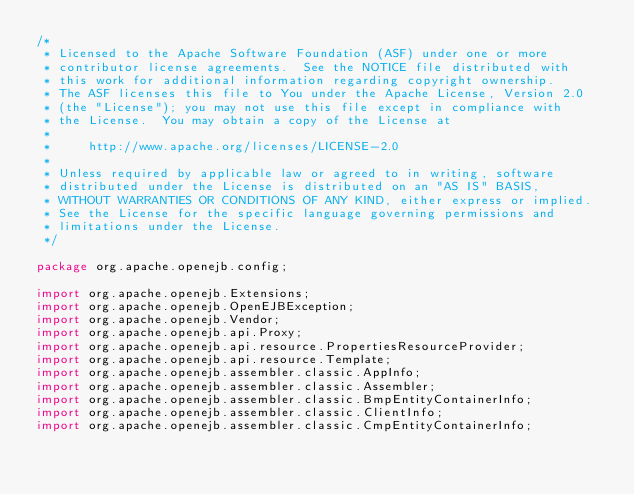Convert code to text. <code><loc_0><loc_0><loc_500><loc_500><_Java_>/*
 * Licensed to the Apache Software Foundation (ASF) under one or more
 * contributor license agreements.  See the NOTICE file distributed with
 * this work for additional information regarding copyright ownership.
 * The ASF licenses this file to You under the Apache License, Version 2.0
 * (the "License"); you may not use this file except in compliance with
 * the License.  You may obtain a copy of the License at
 *
 *     http://www.apache.org/licenses/LICENSE-2.0
 *
 * Unless required by applicable law or agreed to in writing, software
 * distributed under the License is distributed on an "AS IS" BASIS,
 * WITHOUT WARRANTIES OR CONDITIONS OF ANY KIND, either express or implied.
 * See the License for the specific language governing permissions and
 * limitations under the License.
 */

package org.apache.openejb.config;

import org.apache.openejb.Extensions;
import org.apache.openejb.OpenEJBException;
import org.apache.openejb.Vendor;
import org.apache.openejb.api.Proxy;
import org.apache.openejb.api.resource.PropertiesResourceProvider;
import org.apache.openejb.api.resource.Template;
import org.apache.openejb.assembler.classic.AppInfo;
import org.apache.openejb.assembler.classic.Assembler;
import org.apache.openejb.assembler.classic.BmpEntityContainerInfo;
import org.apache.openejb.assembler.classic.ClientInfo;
import org.apache.openejb.assembler.classic.CmpEntityContainerInfo;</code> 